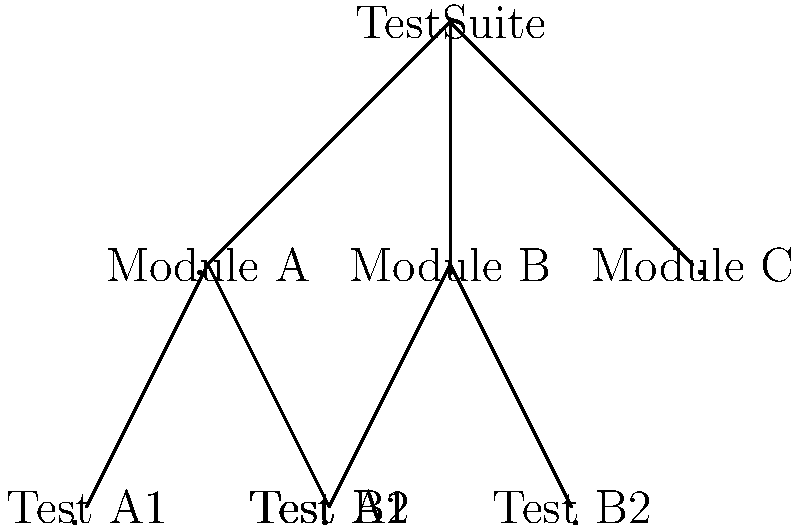In the given tree diagram representing a test suite hierarchy, what is the maximum depth of the tree, and how many leaf nodes (individual test cases) are present? To answer this question, we need to analyze the structure of the tree diagram:

1. Identify the root node:
   - The root node is "TestSuite"

2. Examine the levels of the tree:
   - Level 0: TestSuite (root)
   - Level 1: Module A, Module B, Module C
   - Level 2: Test A1, Test A2, Test B1, Test B2

3. Calculate the maximum depth:
   - The maximum depth is the number of edges from the root to the deepest leaf node
   - In this case, it's 2 (TestSuite -> Module A -> Test A1, for example)

4. Count the leaf nodes:
   - Leaf nodes are nodes with no children
   - In this diagram, the leaf nodes are: Test A1, Test A2, Test B1, Test B2, and Module C
   - Total number of leaf nodes: 5

Therefore, the maximum depth of the tree is 2, and there are 5 leaf nodes (individual test cases) present.
Answer: Maximum depth: 2, Leaf nodes: 5 